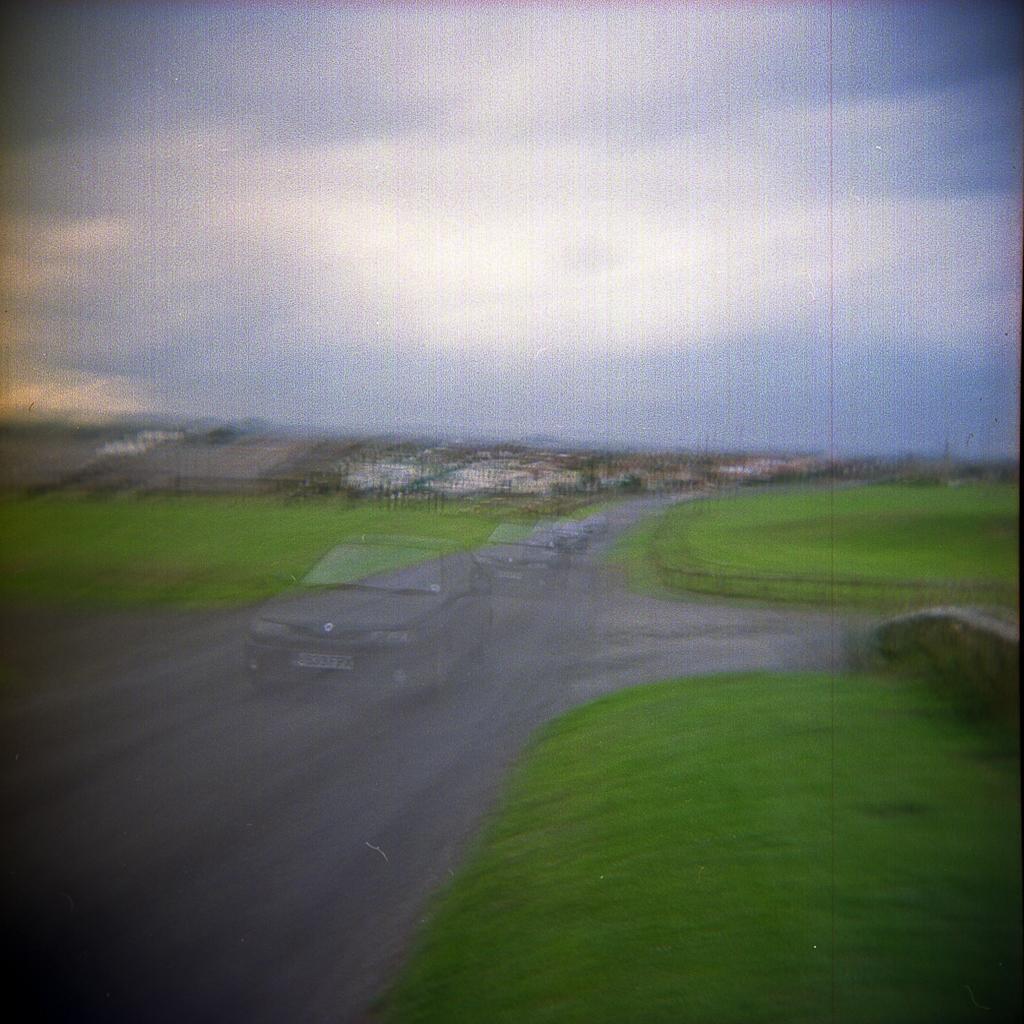Describe this image in one or two sentences. It is a graphic picture. In the image in the center, we can see a few vehicles on the road. In the background, we can see the sky, clouds, buildings, grass etc. 